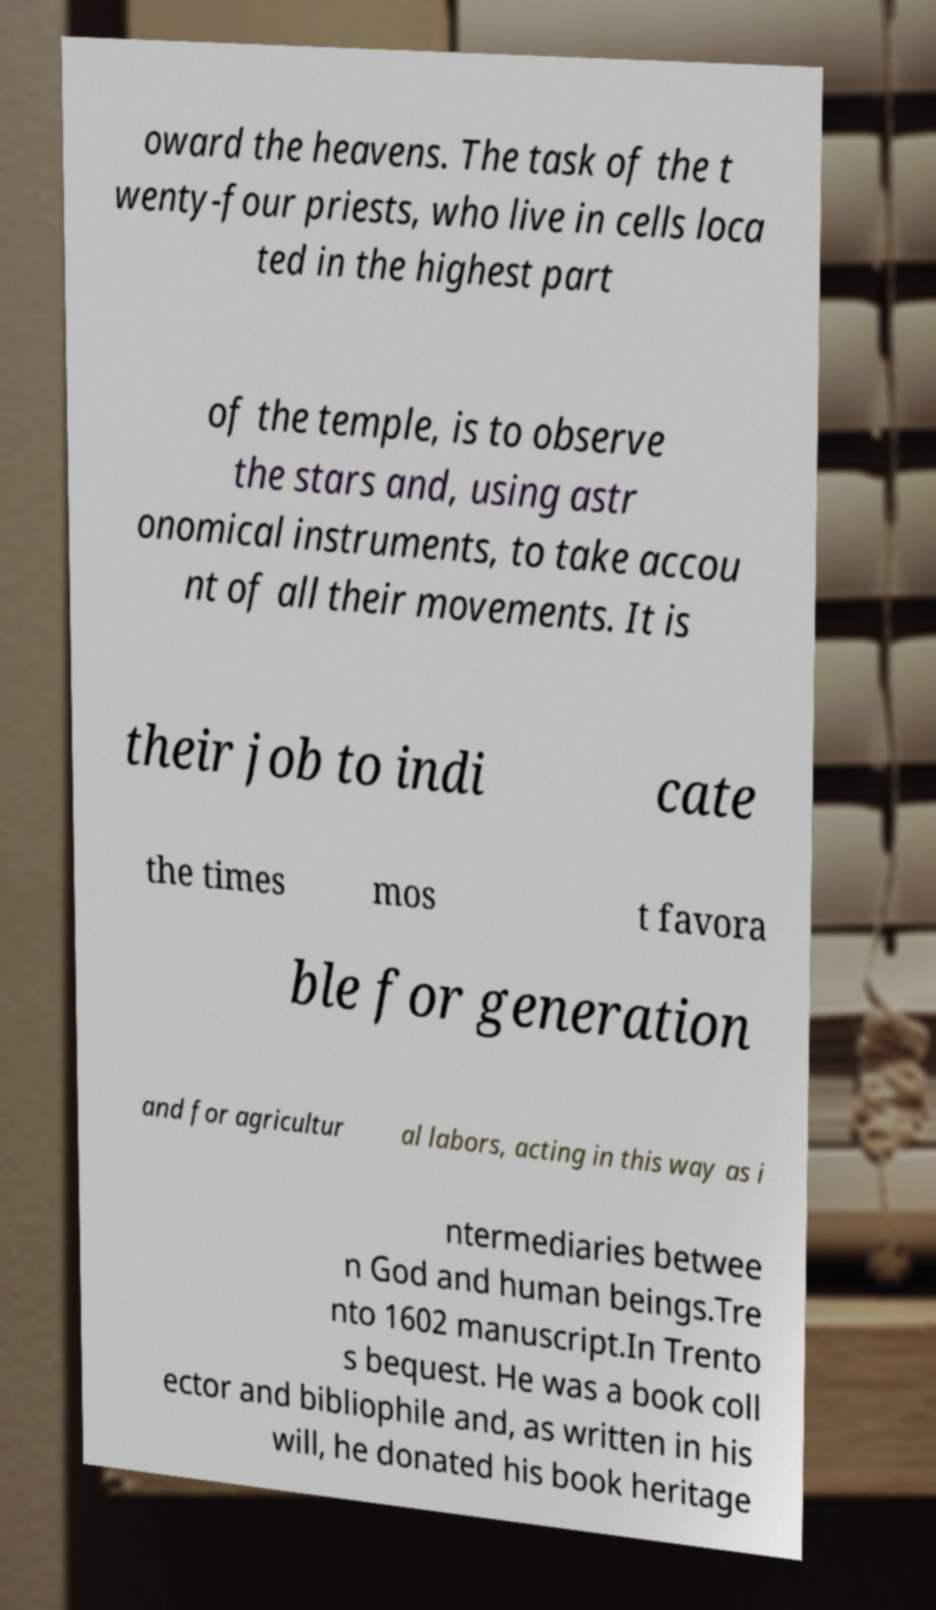For documentation purposes, I need the text within this image transcribed. Could you provide that? oward the heavens. The task of the t wenty-four priests, who live in cells loca ted in the highest part of the temple, is to observe the stars and, using astr onomical instruments, to take accou nt of all their movements. It is their job to indi cate the times mos t favora ble for generation and for agricultur al labors, acting in this way as i ntermediaries betwee n God and human beings.Tre nto 1602 manuscript.In Trento s bequest. He was a book coll ector and bibliophile and, as written in his will, he donated his book heritage 